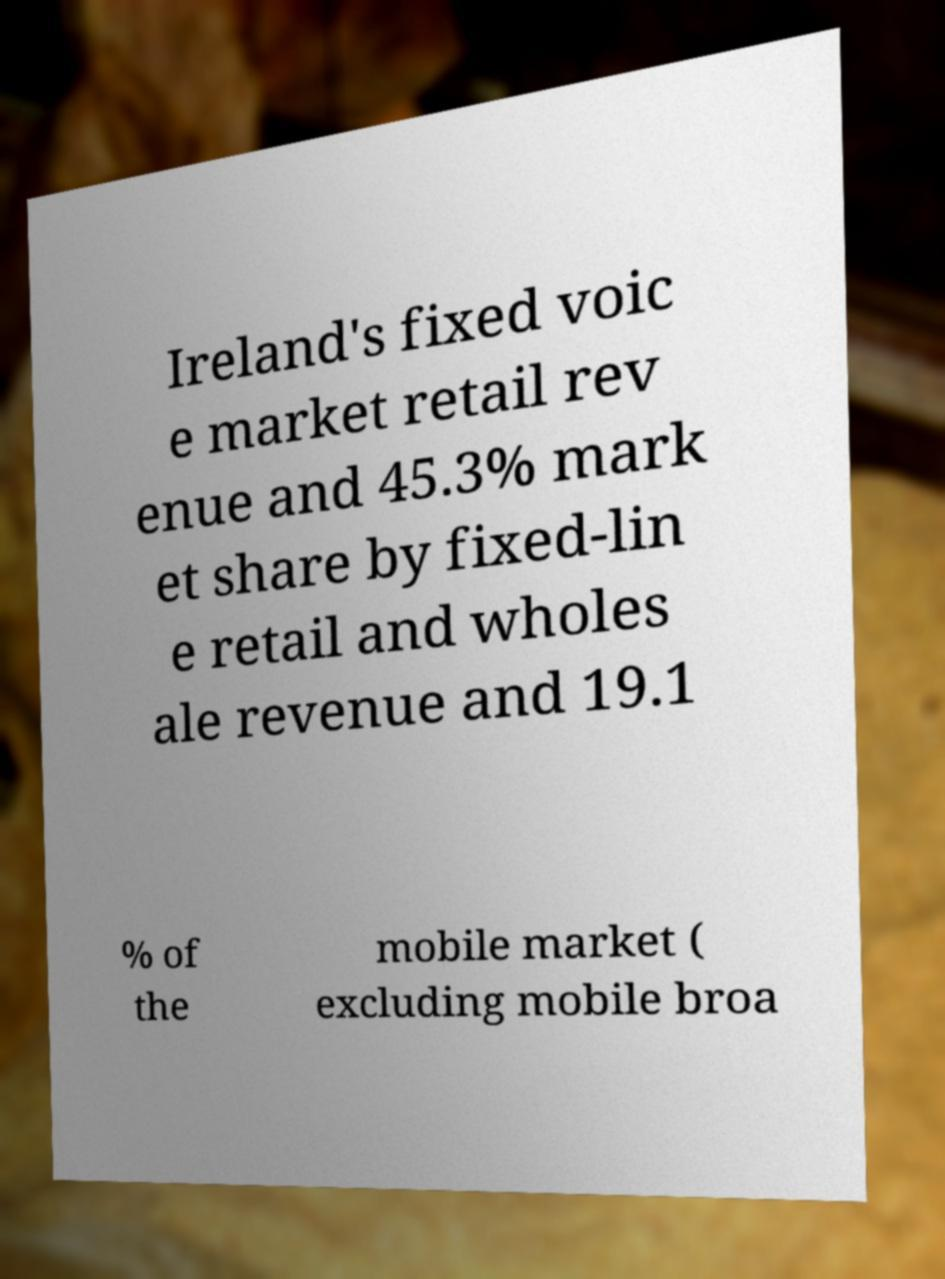For documentation purposes, I need the text within this image transcribed. Could you provide that? Ireland's fixed voic e market retail rev enue and 45.3% mark et share by fixed-lin e retail and wholes ale revenue and 19.1 % of the mobile market ( excluding mobile broa 